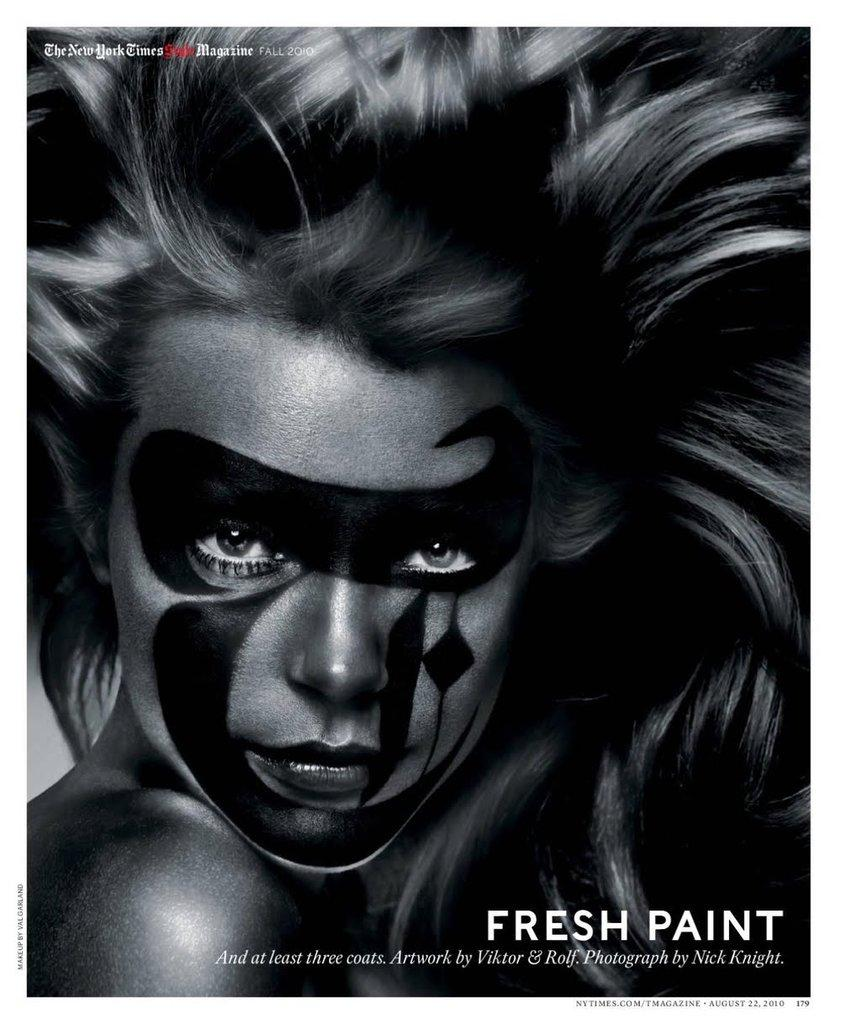What is the color scheme of the image? The image is black and white. Who is present in the image? There is a girl in the image. What is a noticeable feature of the girl? The girl has paint on her face. Is there any additional information or branding in the image? Yes, there is a watermark in the right bottom corner of the image. How many beds are visible in the image? There are no beds present in the image. What is the coast like in the image? There is no coast visible in the image. 